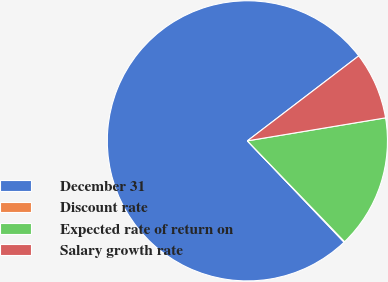Convert chart. <chart><loc_0><loc_0><loc_500><loc_500><pie_chart><fcel>December 31<fcel>Discount rate<fcel>Expected rate of return on<fcel>Salary growth rate<nl><fcel>76.75%<fcel>0.08%<fcel>15.42%<fcel>7.75%<nl></chart> 